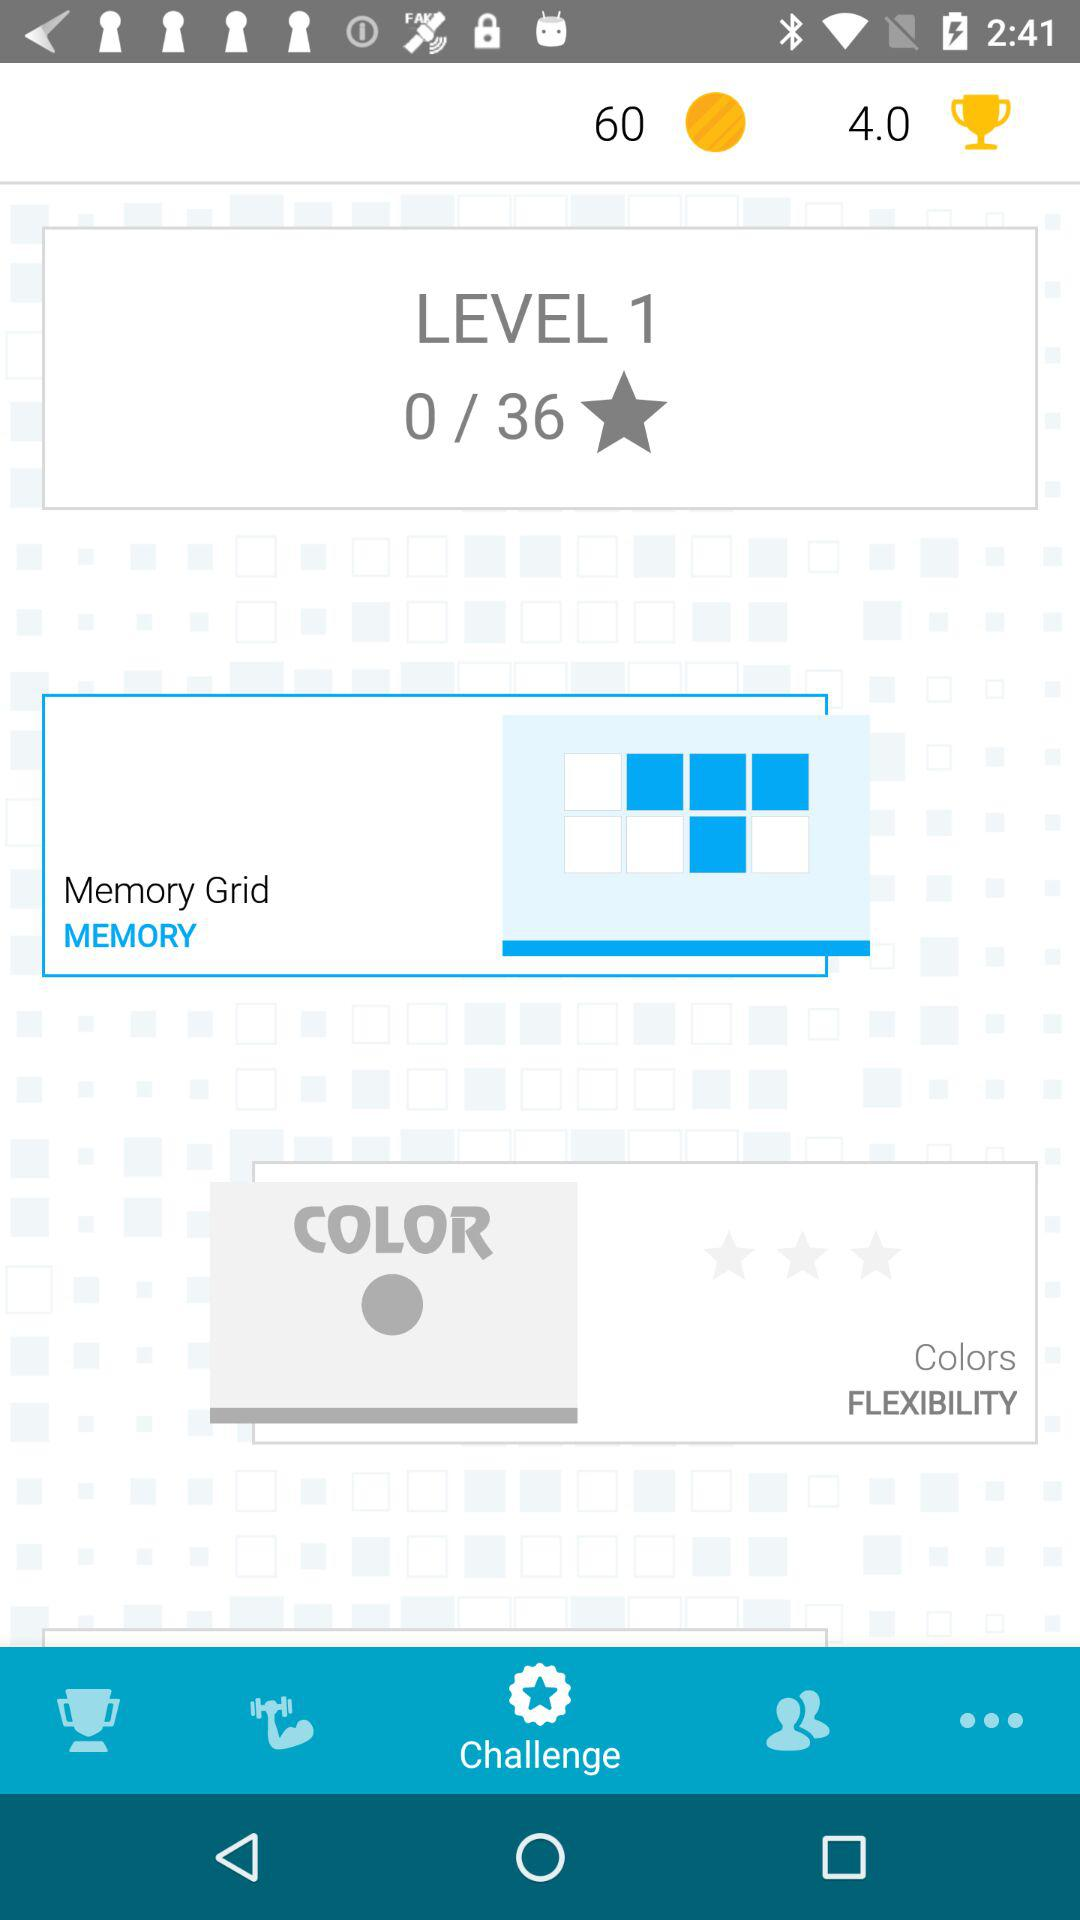Which level am I at? You are at the first level. 